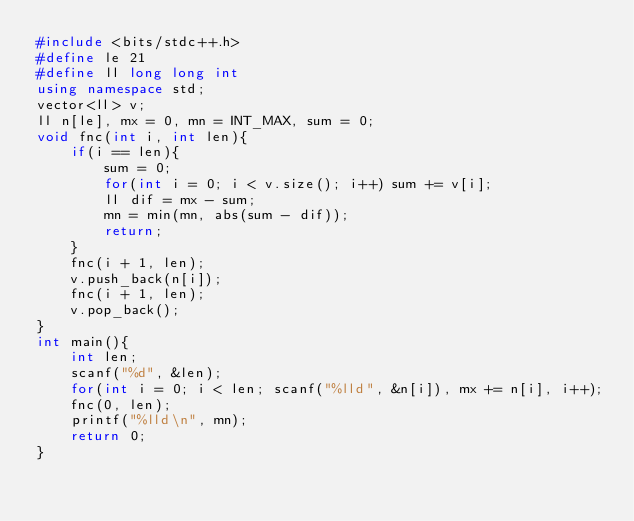Convert code to text. <code><loc_0><loc_0><loc_500><loc_500><_C++_>#include <bits/stdc++.h>
#define le 21
#define ll long long int
using namespace std;
vector<ll> v;
ll n[le], mx = 0, mn = INT_MAX, sum = 0;
void fnc(int i, int len){
	if(i == len){
		sum = 0;
		for(int i = 0; i < v.size(); i++) sum += v[i];
		ll dif = mx - sum;
		mn = min(mn, abs(sum - dif));
		return;
	}
	fnc(i + 1, len);
	v.push_back(n[i]);
	fnc(i + 1, len);
	v.pop_back();
}
int main(){
	int len;
	scanf("%d", &len);
	for(int i = 0; i < len; scanf("%lld", &n[i]), mx += n[i], i++);
	fnc(0, len);
	printf("%lld\n", mn);
	return 0;
}
</code> 